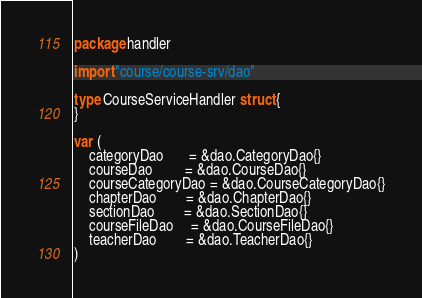Convert code to text. <code><loc_0><loc_0><loc_500><loc_500><_Go_>package handler

import "course/course-srv/dao"

type CourseServiceHandler struct {
}

var (
	categoryDao       = &dao.CategoryDao{}
	courseDao         = &dao.CourseDao{}
	courseCategoryDao = &dao.CourseCategoryDao{}
	chapterDao        = &dao.ChapterDao{}
	sectionDao        = &dao.SectionDao{}
	courseFileDao     = &dao.CourseFileDao{}
	teacherDao        = &dao.TeacherDao{}
)
</code> 